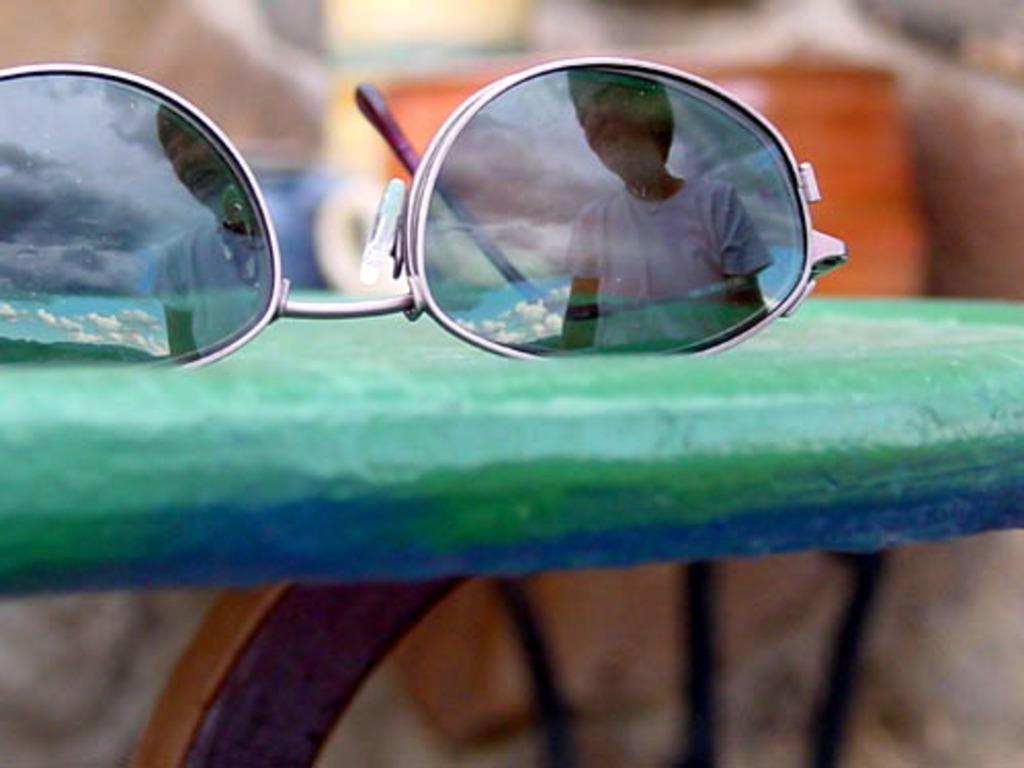Describe this image in one or two sentences. In this image we can see spectacles. 